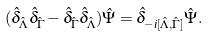Convert formula to latex. <formula><loc_0><loc_0><loc_500><loc_500>( \hat { \delta } _ { \hat { \Lambda } } \hat { \delta } _ { \hat { \Gamma } } - \hat { \delta } _ { \hat { \Gamma } } \hat { \delta } _ { \hat { \Lambda } } ) \hat { \Psi } = \hat { \delta } _ { - i [ \hat { \Lambda } , \hat { \Gamma } ] } \hat { \Psi } .</formula> 